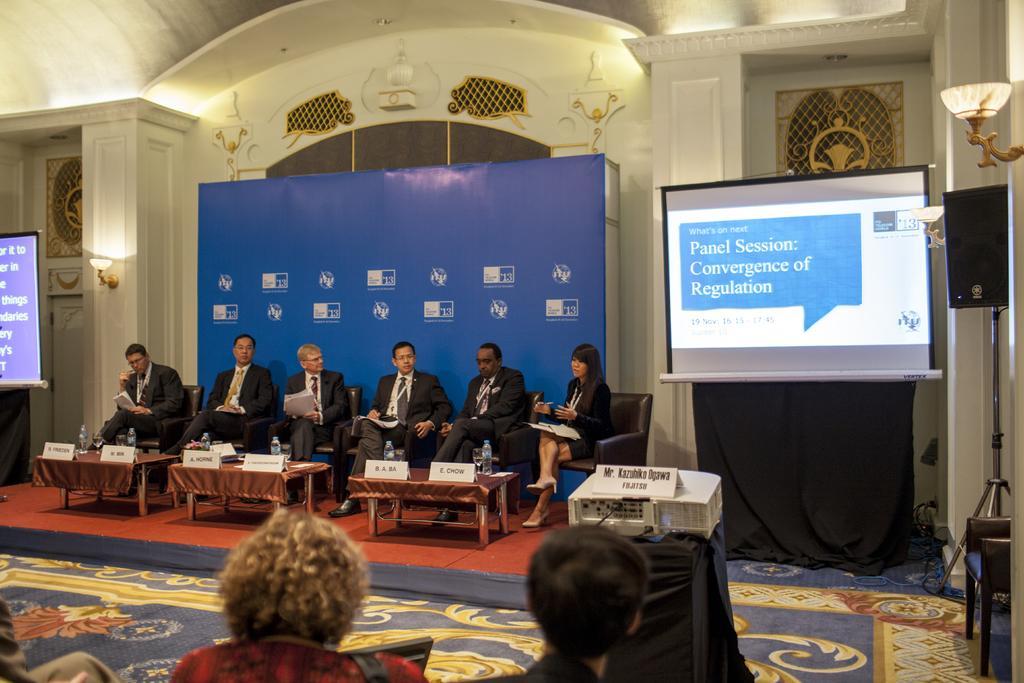How would you summarize this image in a sentence or two? In this image we can see a few people, some of them are holding papers, in front of them there are some tables, on those tables, we can see bottles, boards, with some text on it, there is a speaker on the stand, there are some lights, projector, and two screens with some text on it, there are black clothes, a mat, also we can see the wall, and some sculptures. 